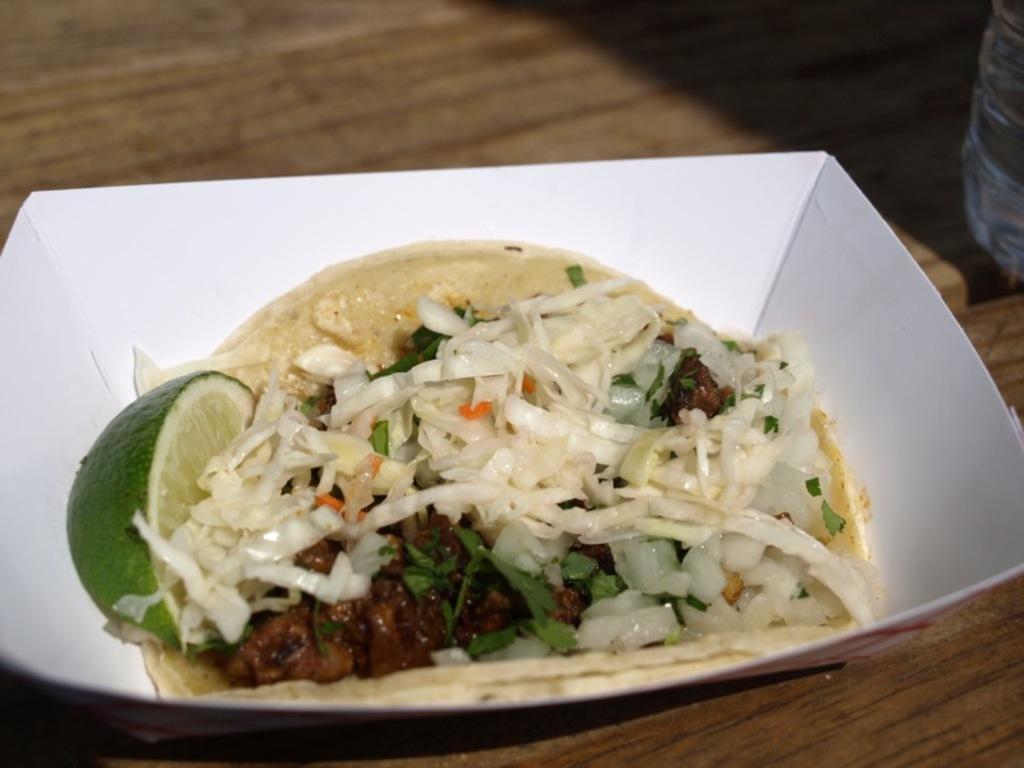Can you describe this image briefly? In this image we can see a food item in the bowl, there are onions, there is a lemon, there is a water bottle on the wooden table. 